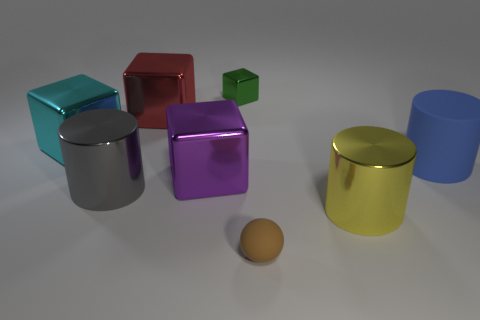Add 1 big blocks. How many objects exist? 9 Subtract all large gray cylinders. How many cylinders are left? 2 Subtract all purple blocks. How many blocks are left? 3 Add 1 brown objects. How many brown objects are left? 2 Add 8 green rubber blocks. How many green rubber blocks exist? 8 Subtract 1 brown balls. How many objects are left? 7 Subtract all balls. How many objects are left? 7 Subtract 1 balls. How many balls are left? 0 Subtract all red cylinders. Subtract all red blocks. How many cylinders are left? 3 Subtract all yellow cylinders. How many gray blocks are left? 0 